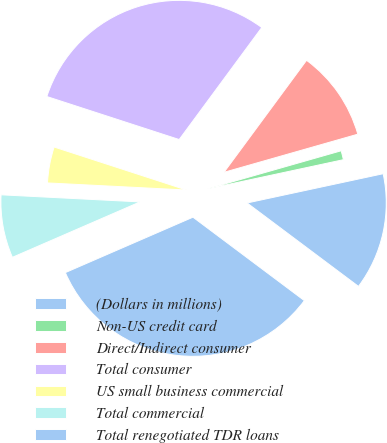Convert chart. <chart><loc_0><loc_0><loc_500><loc_500><pie_chart><fcel>(Dollars in millions)<fcel>Non-US credit card<fcel>Direct/Indirect consumer<fcel>Total consumer<fcel>US small business commercial<fcel>Total commercial<fcel>Total renegotiated TDR loans<nl><fcel>13.6%<fcel>1.05%<fcel>10.47%<fcel>30.11%<fcel>4.19%<fcel>7.33%<fcel>33.25%<nl></chart> 